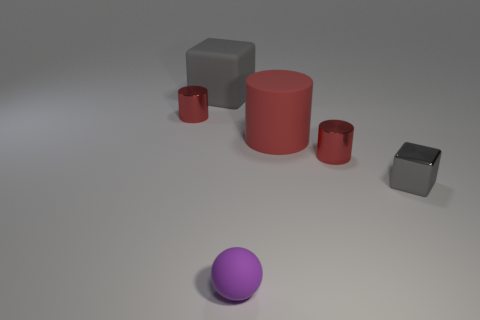What is the material of the tiny object that is both in front of the big cylinder and behind the small metal cube?
Give a very brief answer. Metal. There is a red metal cylinder that is right of the metal cylinder left of the gray matte thing; are there any large red cylinders that are in front of it?
Ensure brevity in your answer.  No. There is another cube that is the same color as the small metallic cube; what is its size?
Your answer should be very brief. Large. Are there any tiny purple balls right of the tiny purple matte thing?
Your response must be concise. No. What number of other objects are there of the same shape as the large red thing?
Ensure brevity in your answer.  2. There is a metal cube that is the same size as the purple rubber thing; what is its color?
Provide a succinct answer. Gray. Are there fewer large gray rubber objects that are right of the gray matte object than tiny shiny cubes right of the tiny metal cube?
Offer a very short reply. No. There is a tiny red cylinder that is in front of the red cylinder left of the red rubber object; what number of tiny metal cubes are to the left of it?
Make the answer very short. 0. What size is the gray matte thing that is the same shape as the gray metallic object?
Make the answer very short. Large. Is there anything else that has the same size as the purple matte object?
Make the answer very short. Yes. 